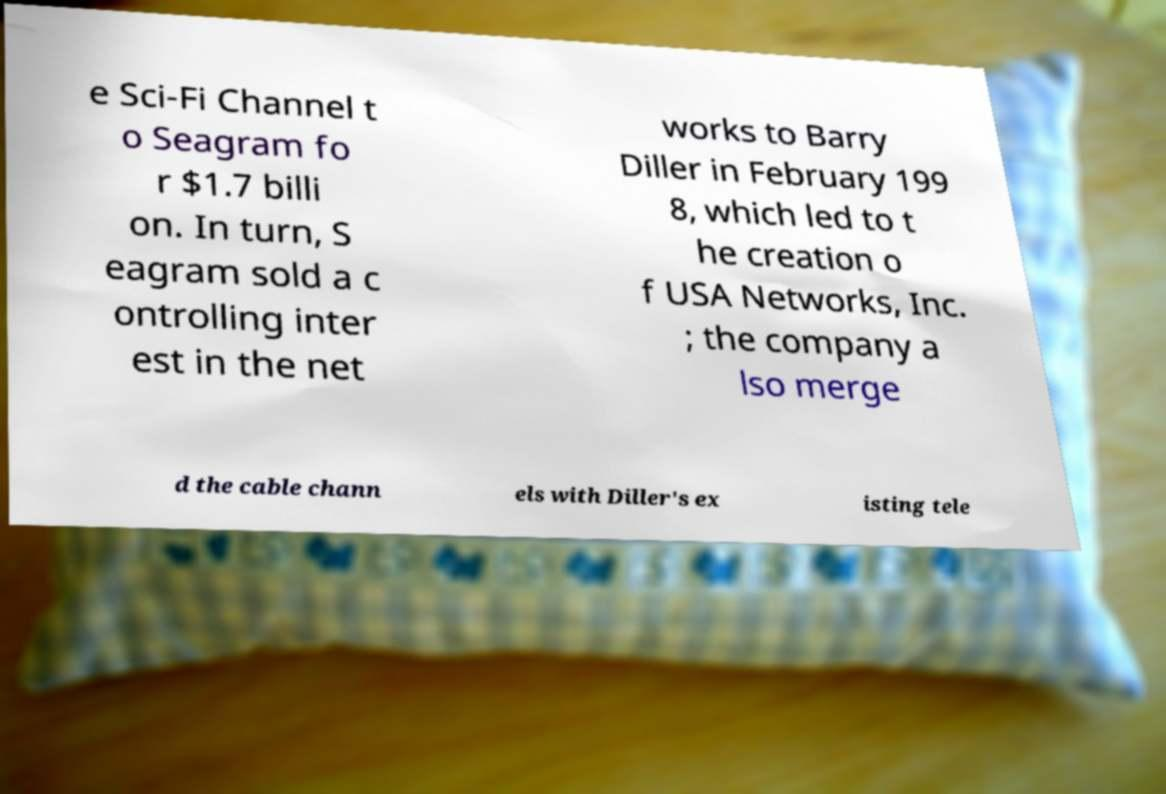What messages or text are displayed in this image? I need them in a readable, typed format. e Sci-Fi Channel t o Seagram fo r $1.7 billi on. In turn, S eagram sold a c ontrolling inter est in the net works to Barry Diller in February 199 8, which led to t he creation o f USA Networks, Inc. ; the company a lso merge d the cable chann els with Diller's ex isting tele 